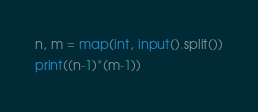Convert code to text. <code><loc_0><loc_0><loc_500><loc_500><_Python_>n, m = map(int, input().split())
print((n-1)*(m-1))</code> 